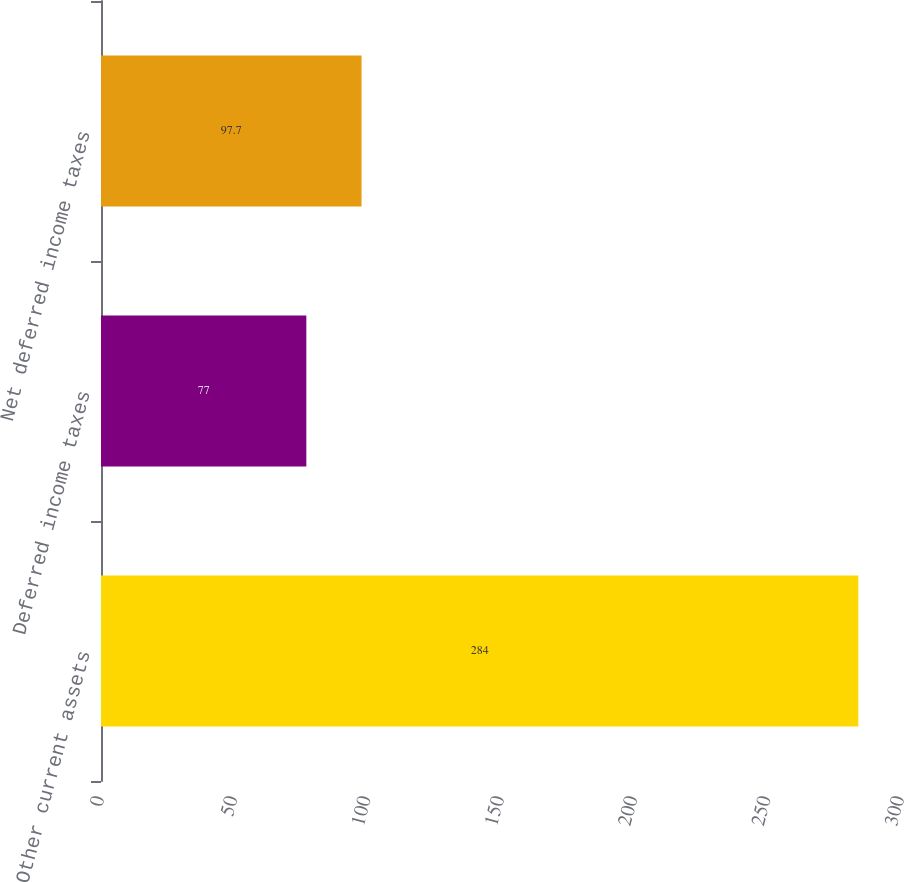<chart> <loc_0><loc_0><loc_500><loc_500><bar_chart><fcel>Other current assets<fcel>Deferred income taxes<fcel>Net deferred income taxes<nl><fcel>284<fcel>77<fcel>97.7<nl></chart> 